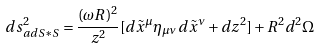Convert formula to latex. <formula><loc_0><loc_0><loc_500><loc_500>d s _ { a d S * S } ^ { 2 } = \frac { ( \omega R ) ^ { 2 } } { z ^ { 2 } } [ d \tilde { x } ^ { \mu } \eta _ { \mu \nu } d \tilde { x } ^ { \nu } + d z ^ { 2 } ] + R ^ { 2 } d ^ { 2 } \Omega</formula> 